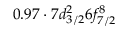<formula> <loc_0><loc_0><loc_500><loc_500>0 . 9 7 \cdot 7 d _ { 3 / 2 } ^ { 2 } 6 f _ { 7 / 2 } ^ { 8 }</formula> 